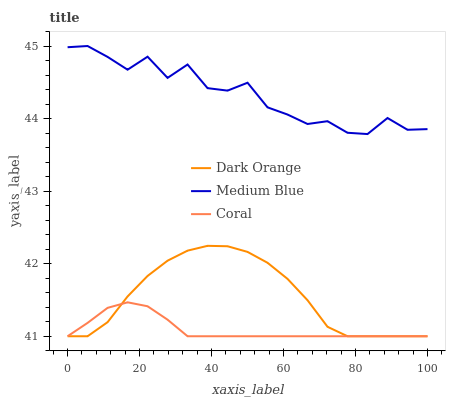Does Coral have the minimum area under the curve?
Answer yes or no. Yes. Does Medium Blue have the maximum area under the curve?
Answer yes or no. Yes. Does Medium Blue have the minimum area under the curve?
Answer yes or no. No. Does Coral have the maximum area under the curve?
Answer yes or no. No. Is Coral the smoothest?
Answer yes or no. Yes. Is Medium Blue the roughest?
Answer yes or no. Yes. Is Medium Blue the smoothest?
Answer yes or no. No. Is Coral the roughest?
Answer yes or no. No. Does Dark Orange have the lowest value?
Answer yes or no. Yes. Does Medium Blue have the lowest value?
Answer yes or no. No. Does Medium Blue have the highest value?
Answer yes or no. Yes. Does Coral have the highest value?
Answer yes or no. No. Is Coral less than Medium Blue?
Answer yes or no. Yes. Is Medium Blue greater than Dark Orange?
Answer yes or no. Yes. Does Dark Orange intersect Coral?
Answer yes or no. Yes. Is Dark Orange less than Coral?
Answer yes or no. No. Is Dark Orange greater than Coral?
Answer yes or no. No. Does Coral intersect Medium Blue?
Answer yes or no. No. 